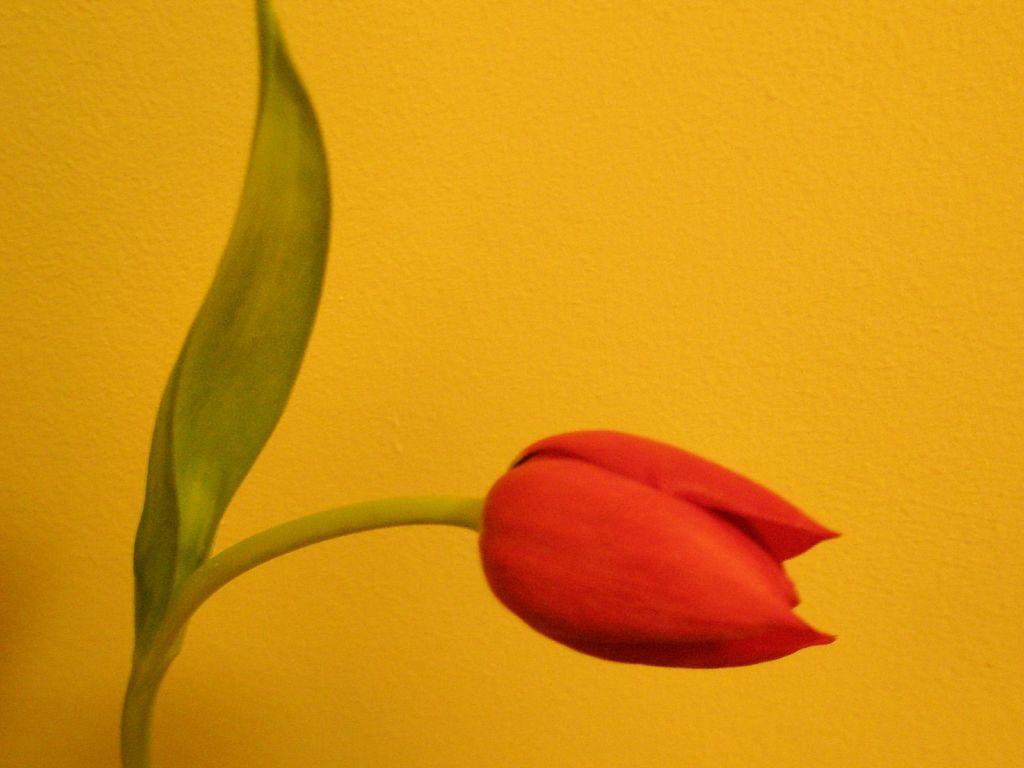In one or two sentences, can you explain what this image depicts? In this image I can see a flower with a leaf. I can also see the background is yellow in color. 